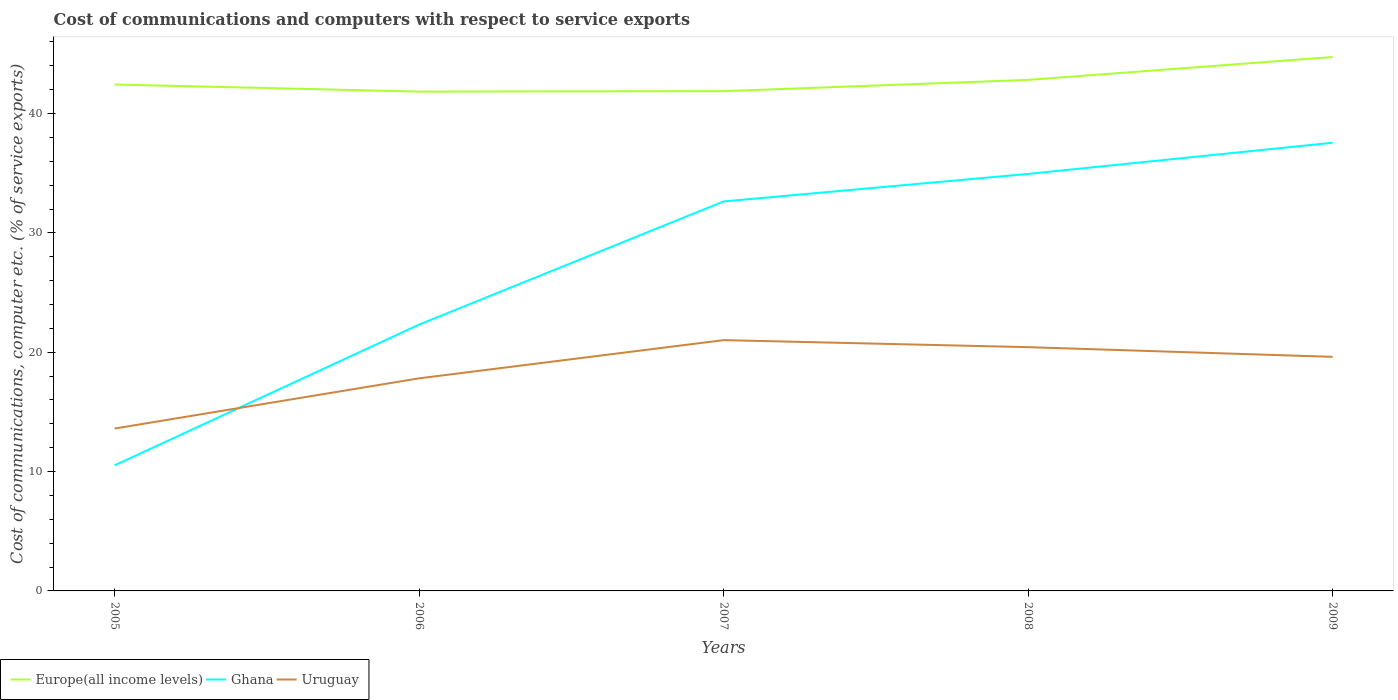Does the line corresponding to Ghana intersect with the line corresponding to Europe(all income levels)?
Offer a very short reply. No. Is the number of lines equal to the number of legend labels?
Give a very brief answer. Yes. Across all years, what is the maximum cost of communications and computers in Ghana?
Offer a terse response. 10.52. What is the total cost of communications and computers in Europe(all income levels) in the graph?
Provide a succinct answer. -0.39. What is the difference between the highest and the second highest cost of communications and computers in Ghana?
Keep it short and to the point. 27.03. How many lines are there?
Your response must be concise. 3. How many years are there in the graph?
Your response must be concise. 5. What is the difference between two consecutive major ticks on the Y-axis?
Offer a very short reply. 10. Does the graph contain grids?
Offer a terse response. No. How many legend labels are there?
Offer a terse response. 3. What is the title of the graph?
Ensure brevity in your answer.  Cost of communications and computers with respect to service exports. What is the label or title of the X-axis?
Offer a terse response. Years. What is the label or title of the Y-axis?
Provide a short and direct response. Cost of communications, computer etc. (% of service exports). What is the Cost of communications, computer etc. (% of service exports) of Europe(all income levels) in 2005?
Ensure brevity in your answer.  42.43. What is the Cost of communications, computer etc. (% of service exports) of Ghana in 2005?
Your answer should be compact. 10.52. What is the Cost of communications, computer etc. (% of service exports) of Uruguay in 2005?
Give a very brief answer. 13.61. What is the Cost of communications, computer etc. (% of service exports) of Europe(all income levels) in 2006?
Offer a very short reply. 41.84. What is the Cost of communications, computer etc. (% of service exports) in Ghana in 2006?
Your answer should be compact. 22.32. What is the Cost of communications, computer etc. (% of service exports) of Uruguay in 2006?
Provide a succinct answer. 17.81. What is the Cost of communications, computer etc. (% of service exports) of Europe(all income levels) in 2007?
Offer a very short reply. 41.88. What is the Cost of communications, computer etc. (% of service exports) of Ghana in 2007?
Your answer should be compact. 32.64. What is the Cost of communications, computer etc. (% of service exports) in Uruguay in 2007?
Make the answer very short. 21.01. What is the Cost of communications, computer etc. (% of service exports) of Europe(all income levels) in 2008?
Provide a short and direct response. 42.82. What is the Cost of communications, computer etc. (% of service exports) in Ghana in 2008?
Provide a succinct answer. 34.94. What is the Cost of communications, computer etc. (% of service exports) of Uruguay in 2008?
Make the answer very short. 20.43. What is the Cost of communications, computer etc. (% of service exports) in Europe(all income levels) in 2009?
Offer a terse response. 44.74. What is the Cost of communications, computer etc. (% of service exports) of Ghana in 2009?
Offer a very short reply. 37.56. What is the Cost of communications, computer etc. (% of service exports) in Uruguay in 2009?
Offer a very short reply. 19.61. Across all years, what is the maximum Cost of communications, computer etc. (% of service exports) in Europe(all income levels)?
Provide a succinct answer. 44.74. Across all years, what is the maximum Cost of communications, computer etc. (% of service exports) in Ghana?
Give a very brief answer. 37.56. Across all years, what is the maximum Cost of communications, computer etc. (% of service exports) of Uruguay?
Keep it short and to the point. 21.01. Across all years, what is the minimum Cost of communications, computer etc. (% of service exports) of Europe(all income levels)?
Make the answer very short. 41.84. Across all years, what is the minimum Cost of communications, computer etc. (% of service exports) of Ghana?
Your answer should be very brief. 10.52. Across all years, what is the minimum Cost of communications, computer etc. (% of service exports) of Uruguay?
Ensure brevity in your answer.  13.61. What is the total Cost of communications, computer etc. (% of service exports) of Europe(all income levels) in the graph?
Your response must be concise. 213.71. What is the total Cost of communications, computer etc. (% of service exports) of Ghana in the graph?
Give a very brief answer. 137.97. What is the total Cost of communications, computer etc. (% of service exports) in Uruguay in the graph?
Offer a very short reply. 92.48. What is the difference between the Cost of communications, computer etc. (% of service exports) of Europe(all income levels) in 2005 and that in 2006?
Offer a very short reply. 0.59. What is the difference between the Cost of communications, computer etc. (% of service exports) in Ghana in 2005 and that in 2006?
Your response must be concise. -11.8. What is the difference between the Cost of communications, computer etc. (% of service exports) in Uruguay in 2005 and that in 2006?
Ensure brevity in your answer.  -4.21. What is the difference between the Cost of communications, computer etc. (% of service exports) of Europe(all income levels) in 2005 and that in 2007?
Give a very brief answer. 0.56. What is the difference between the Cost of communications, computer etc. (% of service exports) of Ghana in 2005 and that in 2007?
Your response must be concise. -22.11. What is the difference between the Cost of communications, computer etc. (% of service exports) in Uruguay in 2005 and that in 2007?
Your answer should be very brief. -7.41. What is the difference between the Cost of communications, computer etc. (% of service exports) of Europe(all income levels) in 2005 and that in 2008?
Offer a very short reply. -0.39. What is the difference between the Cost of communications, computer etc. (% of service exports) in Ghana in 2005 and that in 2008?
Give a very brief answer. -24.42. What is the difference between the Cost of communications, computer etc. (% of service exports) in Uruguay in 2005 and that in 2008?
Your answer should be very brief. -6.82. What is the difference between the Cost of communications, computer etc. (% of service exports) of Europe(all income levels) in 2005 and that in 2009?
Keep it short and to the point. -2.31. What is the difference between the Cost of communications, computer etc. (% of service exports) in Ghana in 2005 and that in 2009?
Give a very brief answer. -27.03. What is the difference between the Cost of communications, computer etc. (% of service exports) of Uruguay in 2005 and that in 2009?
Your answer should be very brief. -6.01. What is the difference between the Cost of communications, computer etc. (% of service exports) of Europe(all income levels) in 2006 and that in 2007?
Provide a succinct answer. -0.04. What is the difference between the Cost of communications, computer etc. (% of service exports) in Ghana in 2006 and that in 2007?
Your answer should be very brief. -10.32. What is the difference between the Cost of communications, computer etc. (% of service exports) of Uruguay in 2006 and that in 2007?
Offer a terse response. -3.2. What is the difference between the Cost of communications, computer etc. (% of service exports) in Europe(all income levels) in 2006 and that in 2008?
Your answer should be compact. -0.98. What is the difference between the Cost of communications, computer etc. (% of service exports) of Ghana in 2006 and that in 2008?
Keep it short and to the point. -12.63. What is the difference between the Cost of communications, computer etc. (% of service exports) in Uruguay in 2006 and that in 2008?
Provide a succinct answer. -2.61. What is the difference between the Cost of communications, computer etc. (% of service exports) in Europe(all income levels) in 2006 and that in 2009?
Your answer should be compact. -2.9. What is the difference between the Cost of communications, computer etc. (% of service exports) in Ghana in 2006 and that in 2009?
Ensure brevity in your answer.  -15.24. What is the difference between the Cost of communications, computer etc. (% of service exports) of Uruguay in 2006 and that in 2009?
Keep it short and to the point. -1.8. What is the difference between the Cost of communications, computer etc. (% of service exports) of Europe(all income levels) in 2007 and that in 2008?
Give a very brief answer. -0.94. What is the difference between the Cost of communications, computer etc. (% of service exports) of Ghana in 2007 and that in 2008?
Offer a terse response. -2.31. What is the difference between the Cost of communications, computer etc. (% of service exports) of Uruguay in 2007 and that in 2008?
Your answer should be very brief. 0.59. What is the difference between the Cost of communications, computer etc. (% of service exports) of Europe(all income levels) in 2007 and that in 2009?
Your answer should be compact. -2.86. What is the difference between the Cost of communications, computer etc. (% of service exports) in Ghana in 2007 and that in 2009?
Your answer should be compact. -4.92. What is the difference between the Cost of communications, computer etc. (% of service exports) of Uruguay in 2007 and that in 2009?
Make the answer very short. 1.4. What is the difference between the Cost of communications, computer etc. (% of service exports) of Europe(all income levels) in 2008 and that in 2009?
Ensure brevity in your answer.  -1.92. What is the difference between the Cost of communications, computer etc. (% of service exports) of Ghana in 2008 and that in 2009?
Make the answer very short. -2.61. What is the difference between the Cost of communications, computer etc. (% of service exports) of Uruguay in 2008 and that in 2009?
Your response must be concise. 0.81. What is the difference between the Cost of communications, computer etc. (% of service exports) of Europe(all income levels) in 2005 and the Cost of communications, computer etc. (% of service exports) of Ghana in 2006?
Provide a short and direct response. 20.12. What is the difference between the Cost of communications, computer etc. (% of service exports) of Europe(all income levels) in 2005 and the Cost of communications, computer etc. (% of service exports) of Uruguay in 2006?
Offer a very short reply. 24.62. What is the difference between the Cost of communications, computer etc. (% of service exports) of Ghana in 2005 and the Cost of communications, computer etc. (% of service exports) of Uruguay in 2006?
Give a very brief answer. -7.29. What is the difference between the Cost of communications, computer etc. (% of service exports) of Europe(all income levels) in 2005 and the Cost of communications, computer etc. (% of service exports) of Ghana in 2007?
Provide a succinct answer. 9.8. What is the difference between the Cost of communications, computer etc. (% of service exports) in Europe(all income levels) in 2005 and the Cost of communications, computer etc. (% of service exports) in Uruguay in 2007?
Your answer should be very brief. 21.42. What is the difference between the Cost of communications, computer etc. (% of service exports) in Ghana in 2005 and the Cost of communications, computer etc. (% of service exports) in Uruguay in 2007?
Keep it short and to the point. -10.49. What is the difference between the Cost of communications, computer etc. (% of service exports) in Europe(all income levels) in 2005 and the Cost of communications, computer etc. (% of service exports) in Ghana in 2008?
Offer a terse response. 7.49. What is the difference between the Cost of communications, computer etc. (% of service exports) of Europe(all income levels) in 2005 and the Cost of communications, computer etc. (% of service exports) of Uruguay in 2008?
Ensure brevity in your answer.  22.01. What is the difference between the Cost of communications, computer etc. (% of service exports) in Ghana in 2005 and the Cost of communications, computer etc. (% of service exports) in Uruguay in 2008?
Ensure brevity in your answer.  -9.9. What is the difference between the Cost of communications, computer etc. (% of service exports) in Europe(all income levels) in 2005 and the Cost of communications, computer etc. (% of service exports) in Ghana in 2009?
Provide a succinct answer. 4.88. What is the difference between the Cost of communications, computer etc. (% of service exports) of Europe(all income levels) in 2005 and the Cost of communications, computer etc. (% of service exports) of Uruguay in 2009?
Offer a very short reply. 22.82. What is the difference between the Cost of communications, computer etc. (% of service exports) of Ghana in 2005 and the Cost of communications, computer etc. (% of service exports) of Uruguay in 2009?
Your response must be concise. -9.09. What is the difference between the Cost of communications, computer etc. (% of service exports) of Europe(all income levels) in 2006 and the Cost of communications, computer etc. (% of service exports) of Ghana in 2007?
Offer a very short reply. 9.21. What is the difference between the Cost of communications, computer etc. (% of service exports) in Europe(all income levels) in 2006 and the Cost of communications, computer etc. (% of service exports) in Uruguay in 2007?
Ensure brevity in your answer.  20.83. What is the difference between the Cost of communications, computer etc. (% of service exports) in Ghana in 2006 and the Cost of communications, computer etc. (% of service exports) in Uruguay in 2007?
Keep it short and to the point. 1.3. What is the difference between the Cost of communications, computer etc. (% of service exports) in Europe(all income levels) in 2006 and the Cost of communications, computer etc. (% of service exports) in Ghana in 2008?
Provide a short and direct response. 6.9. What is the difference between the Cost of communications, computer etc. (% of service exports) in Europe(all income levels) in 2006 and the Cost of communications, computer etc. (% of service exports) in Uruguay in 2008?
Ensure brevity in your answer.  21.42. What is the difference between the Cost of communications, computer etc. (% of service exports) of Ghana in 2006 and the Cost of communications, computer etc. (% of service exports) of Uruguay in 2008?
Make the answer very short. 1.89. What is the difference between the Cost of communications, computer etc. (% of service exports) of Europe(all income levels) in 2006 and the Cost of communications, computer etc. (% of service exports) of Ghana in 2009?
Provide a short and direct response. 4.29. What is the difference between the Cost of communications, computer etc. (% of service exports) of Europe(all income levels) in 2006 and the Cost of communications, computer etc. (% of service exports) of Uruguay in 2009?
Keep it short and to the point. 22.23. What is the difference between the Cost of communications, computer etc. (% of service exports) of Ghana in 2006 and the Cost of communications, computer etc. (% of service exports) of Uruguay in 2009?
Your answer should be very brief. 2.7. What is the difference between the Cost of communications, computer etc. (% of service exports) in Europe(all income levels) in 2007 and the Cost of communications, computer etc. (% of service exports) in Ghana in 2008?
Provide a succinct answer. 6.94. What is the difference between the Cost of communications, computer etc. (% of service exports) in Europe(all income levels) in 2007 and the Cost of communications, computer etc. (% of service exports) in Uruguay in 2008?
Your answer should be very brief. 21.45. What is the difference between the Cost of communications, computer etc. (% of service exports) in Ghana in 2007 and the Cost of communications, computer etc. (% of service exports) in Uruguay in 2008?
Your response must be concise. 12.21. What is the difference between the Cost of communications, computer etc. (% of service exports) of Europe(all income levels) in 2007 and the Cost of communications, computer etc. (% of service exports) of Ghana in 2009?
Provide a short and direct response. 4.32. What is the difference between the Cost of communications, computer etc. (% of service exports) of Europe(all income levels) in 2007 and the Cost of communications, computer etc. (% of service exports) of Uruguay in 2009?
Make the answer very short. 22.26. What is the difference between the Cost of communications, computer etc. (% of service exports) in Ghana in 2007 and the Cost of communications, computer etc. (% of service exports) in Uruguay in 2009?
Ensure brevity in your answer.  13.02. What is the difference between the Cost of communications, computer etc. (% of service exports) of Europe(all income levels) in 2008 and the Cost of communications, computer etc. (% of service exports) of Ghana in 2009?
Give a very brief answer. 5.27. What is the difference between the Cost of communications, computer etc. (% of service exports) in Europe(all income levels) in 2008 and the Cost of communications, computer etc. (% of service exports) in Uruguay in 2009?
Give a very brief answer. 23.21. What is the difference between the Cost of communications, computer etc. (% of service exports) of Ghana in 2008 and the Cost of communications, computer etc. (% of service exports) of Uruguay in 2009?
Keep it short and to the point. 15.33. What is the average Cost of communications, computer etc. (% of service exports) in Europe(all income levels) per year?
Offer a very short reply. 42.74. What is the average Cost of communications, computer etc. (% of service exports) in Ghana per year?
Provide a short and direct response. 27.59. What is the average Cost of communications, computer etc. (% of service exports) in Uruguay per year?
Your response must be concise. 18.5. In the year 2005, what is the difference between the Cost of communications, computer etc. (% of service exports) of Europe(all income levels) and Cost of communications, computer etc. (% of service exports) of Ghana?
Offer a terse response. 31.91. In the year 2005, what is the difference between the Cost of communications, computer etc. (% of service exports) of Europe(all income levels) and Cost of communications, computer etc. (% of service exports) of Uruguay?
Your answer should be very brief. 28.83. In the year 2005, what is the difference between the Cost of communications, computer etc. (% of service exports) in Ghana and Cost of communications, computer etc. (% of service exports) in Uruguay?
Keep it short and to the point. -3.09. In the year 2006, what is the difference between the Cost of communications, computer etc. (% of service exports) of Europe(all income levels) and Cost of communications, computer etc. (% of service exports) of Ghana?
Your response must be concise. 19.53. In the year 2006, what is the difference between the Cost of communications, computer etc. (% of service exports) in Europe(all income levels) and Cost of communications, computer etc. (% of service exports) in Uruguay?
Your response must be concise. 24.03. In the year 2006, what is the difference between the Cost of communications, computer etc. (% of service exports) of Ghana and Cost of communications, computer etc. (% of service exports) of Uruguay?
Provide a short and direct response. 4.5. In the year 2007, what is the difference between the Cost of communications, computer etc. (% of service exports) in Europe(all income levels) and Cost of communications, computer etc. (% of service exports) in Ghana?
Ensure brevity in your answer.  9.24. In the year 2007, what is the difference between the Cost of communications, computer etc. (% of service exports) in Europe(all income levels) and Cost of communications, computer etc. (% of service exports) in Uruguay?
Your answer should be very brief. 20.86. In the year 2007, what is the difference between the Cost of communications, computer etc. (% of service exports) in Ghana and Cost of communications, computer etc. (% of service exports) in Uruguay?
Your answer should be very brief. 11.62. In the year 2008, what is the difference between the Cost of communications, computer etc. (% of service exports) in Europe(all income levels) and Cost of communications, computer etc. (% of service exports) in Ghana?
Offer a terse response. 7.88. In the year 2008, what is the difference between the Cost of communications, computer etc. (% of service exports) in Europe(all income levels) and Cost of communications, computer etc. (% of service exports) in Uruguay?
Offer a very short reply. 22.4. In the year 2008, what is the difference between the Cost of communications, computer etc. (% of service exports) in Ghana and Cost of communications, computer etc. (% of service exports) in Uruguay?
Offer a terse response. 14.52. In the year 2009, what is the difference between the Cost of communications, computer etc. (% of service exports) of Europe(all income levels) and Cost of communications, computer etc. (% of service exports) of Ghana?
Make the answer very short. 7.18. In the year 2009, what is the difference between the Cost of communications, computer etc. (% of service exports) in Europe(all income levels) and Cost of communications, computer etc. (% of service exports) in Uruguay?
Make the answer very short. 25.12. In the year 2009, what is the difference between the Cost of communications, computer etc. (% of service exports) in Ghana and Cost of communications, computer etc. (% of service exports) in Uruguay?
Offer a terse response. 17.94. What is the ratio of the Cost of communications, computer etc. (% of service exports) in Europe(all income levels) in 2005 to that in 2006?
Make the answer very short. 1.01. What is the ratio of the Cost of communications, computer etc. (% of service exports) in Ghana in 2005 to that in 2006?
Keep it short and to the point. 0.47. What is the ratio of the Cost of communications, computer etc. (% of service exports) of Uruguay in 2005 to that in 2006?
Provide a short and direct response. 0.76. What is the ratio of the Cost of communications, computer etc. (% of service exports) of Europe(all income levels) in 2005 to that in 2007?
Provide a short and direct response. 1.01. What is the ratio of the Cost of communications, computer etc. (% of service exports) in Ghana in 2005 to that in 2007?
Your answer should be compact. 0.32. What is the ratio of the Cost of communications, computer etc. (% of service exports) in Uruguay in 2005 to that in 2007?
Keep it short and to the point. 0.65. What is the ratio of the Cost of communications, computer etc. (% of service exports) of Europe(all income levels) in 2005 to that in 2008?
Make the answer very short. 0.99. What is the ratio of the Cost of communications, computer etc. (% of service exports) in Ghana in 2005 to that in 2008?
Ensure brevity in your answer.  0.3. What is the ratio of the Cost of communications, computer etc. (% of service exports) of Uruguay in 2005 to that in 2008?
Your answer should be very brief. 0.67. What is the ratio of the Cost of communications, computer etc. (% of service exports) in Europe(all income levels) in 2005 to that in 2009?
Your answer should be very brief. 0.95. What is the ratio of the Cost of communications, computer etc. (% of service exports) in Ghana in 2005 to that in 2009?
Provide a succinct answer. 0.28. What is the ratio of the Cost of communications, computer etc. (% of service exports) of Uruguay in 2005 to that in 2009?
Offer a very short reply. 0.69. What is the ratio of the Cost of communications, computer etc. (% of service exports) of Ghana in 2006 to that in 2007?
Give a very brief answer. 0.68. What is the ratio of the Cost of communications, computer etc. (% of service exports) of Uruguay in 2006 to that in 2007?
Your answer should be very brief. 0.85. What is the ratio of the Cost of communications, computer etc. (% of service exports) of Europe(all income levels) in 2006 to that in 2008?
Provide a succinct answer. 0.98. What is the ratio of the Cost of communications, computer etc. (% of service exports) in Ghana in 2006 to that in 2008?
Provide a succinct answer. 0.64. What is the ratio of the Cost of communications, computer etc. (% of service exports) of Uruguay in 2006 to that in 2008?
Give a very brief answer. 0.87. What is the ratio of the Cost of communications, computer etc. (% of service exports) of Europe(all income levels) in 2006 to that in 2009?
Keep it short and to the point. 0.94. What is the ratio of the Cost of communications, computer etc. (% of service exports) in Ghana in 2006 to that in 2009?
Offer a very short reply. 0.59. What is the ratio of the Cost of communications, computer etc. (% of service exports) in Uruguay in 2006 to that in 2009?
Offer a very short reply. 0.91. What is the ratio of the Cost of communications, computer etc. (% of service exports) of Europe(all income levels) in 2007 to that in 2008?
Provide a short and direct response. 0.98. What is the ratio of the Cost of communications, computer etc. (% of service exports) of Ghana in 2007 to that in 2008?
Offer a terse response. 0.93. What is the ratio of the Cost of communications, computer etc. (% of service exports) of Uruguay in 2007 to that in 2008?
Your answer should be compact. 1.03. What is the ratio of the Cost of communications, computer etc. (% of service exports) of Europe(all income levels) in 2007 to that in 2009?
Your answer should be compact. 0.94. What is the ratio of the Cost of communications, computer etc. (% of service exports) in Ghana in 2007 to that in 2009?
Your answer should be very brief. 0.87. What is the ratio of the Cost of communications, computer etc. (% of service exports) of Uruguay in 2007 to that in 2009?
Keep it short and to the point. 1.07. What is the ratio of the Cost of communications, computer etc. (% of service exports) in Europe(all income levels) in 2008 to that in 2009?
Keep it short and to the point. 0.96. What is the ratio of the Cost of communications, computer etc. (% of service exports) of Ghana in 2008 to that in 2009?
Your answer should be compact. 0.93. What is the ratio of the Cost of communications, computer etc. (% of service exports) in Uruguay in 2008 to that in 2009?
Give a very brief answer. 1.04. What is the difference between the highest and the second highest Cost of communications, computer etc. (% of service exports) in Europe(all income levels)?
Provide a succinct answer. 1.92. What is the difference between the highest and the second highest Cost of communications, computer etc. (% of service exports) in Ghana?
Make the answer very short. 2.61. What is the difference between the highest and the second highest Cost of communications, computer etc. (% of service exports) in Uruguay?
Give a very brief answer. 0.59. What is the difference between the highest and the lowest Cost of communications, computer etc. (% of service exports) of Europe(all income levels)?
Provide a succinct answer. 2.9. What is the difference between the highest and the lowest Cost of communications, computer etc. (% of service exports) of Ghana?
Keep it short and to the point. 27.03. What is the difference between the highest and the lowest Cost of communications, computer etc. (% of service exports) of Uruguay?
Keep it short and to the point. 7.41. 